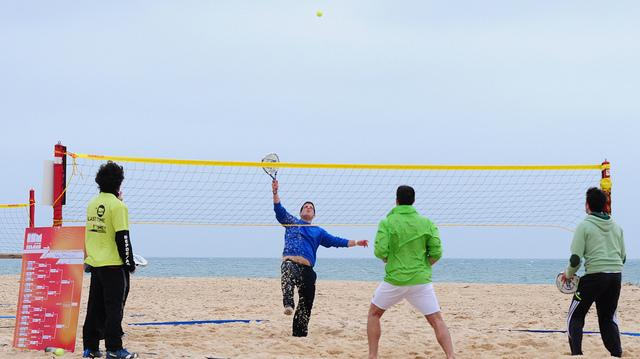What type of net is being played over?

Choices:
A) tennis
B) volleyball
C) fish
D) fencing volleyball 